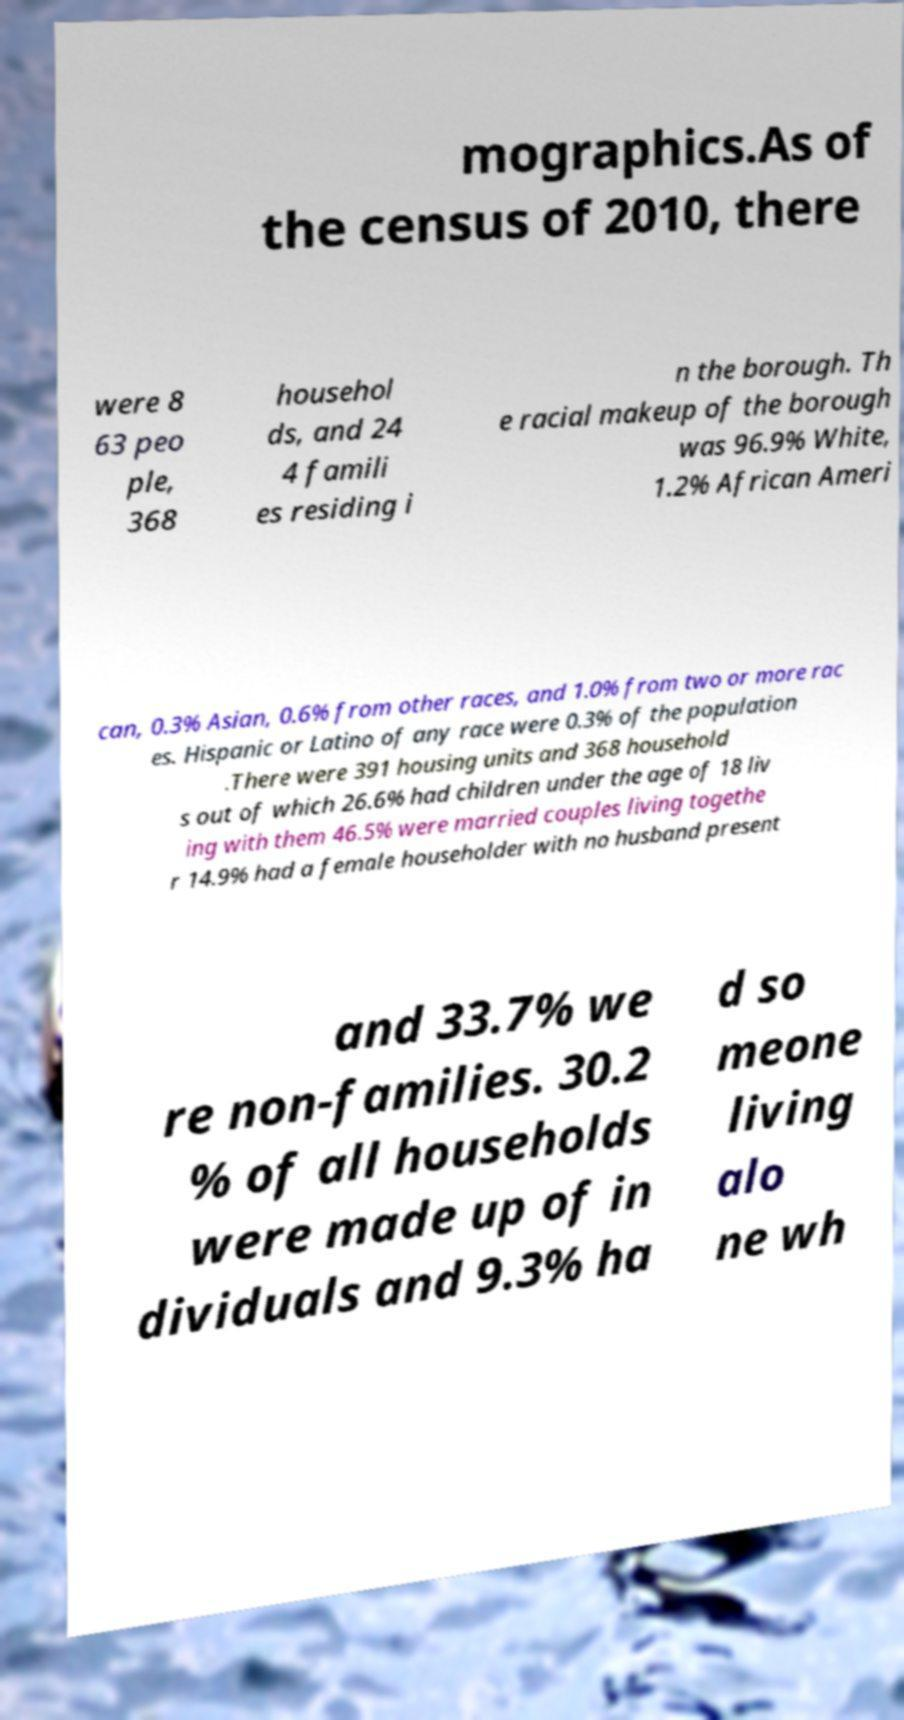Could you assist in decoding the text presented in this image and type it out clearly? mographics.As of the census of 2010, there were 8 63 peo ple, 368 househol ds, and 24 4 famili es residing i n the borough. Th e racial makeup of the borough was 96.9% White, 1.2% African Ameri can, 0.3% Asian, 0.6% from other races, and 1.0% from two or more rac es. Hispanic or Latino of any race were 0.3% of the population .There were 391 housing units and 368 household s out of which 26.6% had children under the age of 18 liv ing with them 46.5% were married couples living togethe r 14.9% had a female householder with no husband present and 33.7% we re non-families. 30.2 % of all households were made up of in dividuals and 9.3% ha d so meone living alo ne wh 